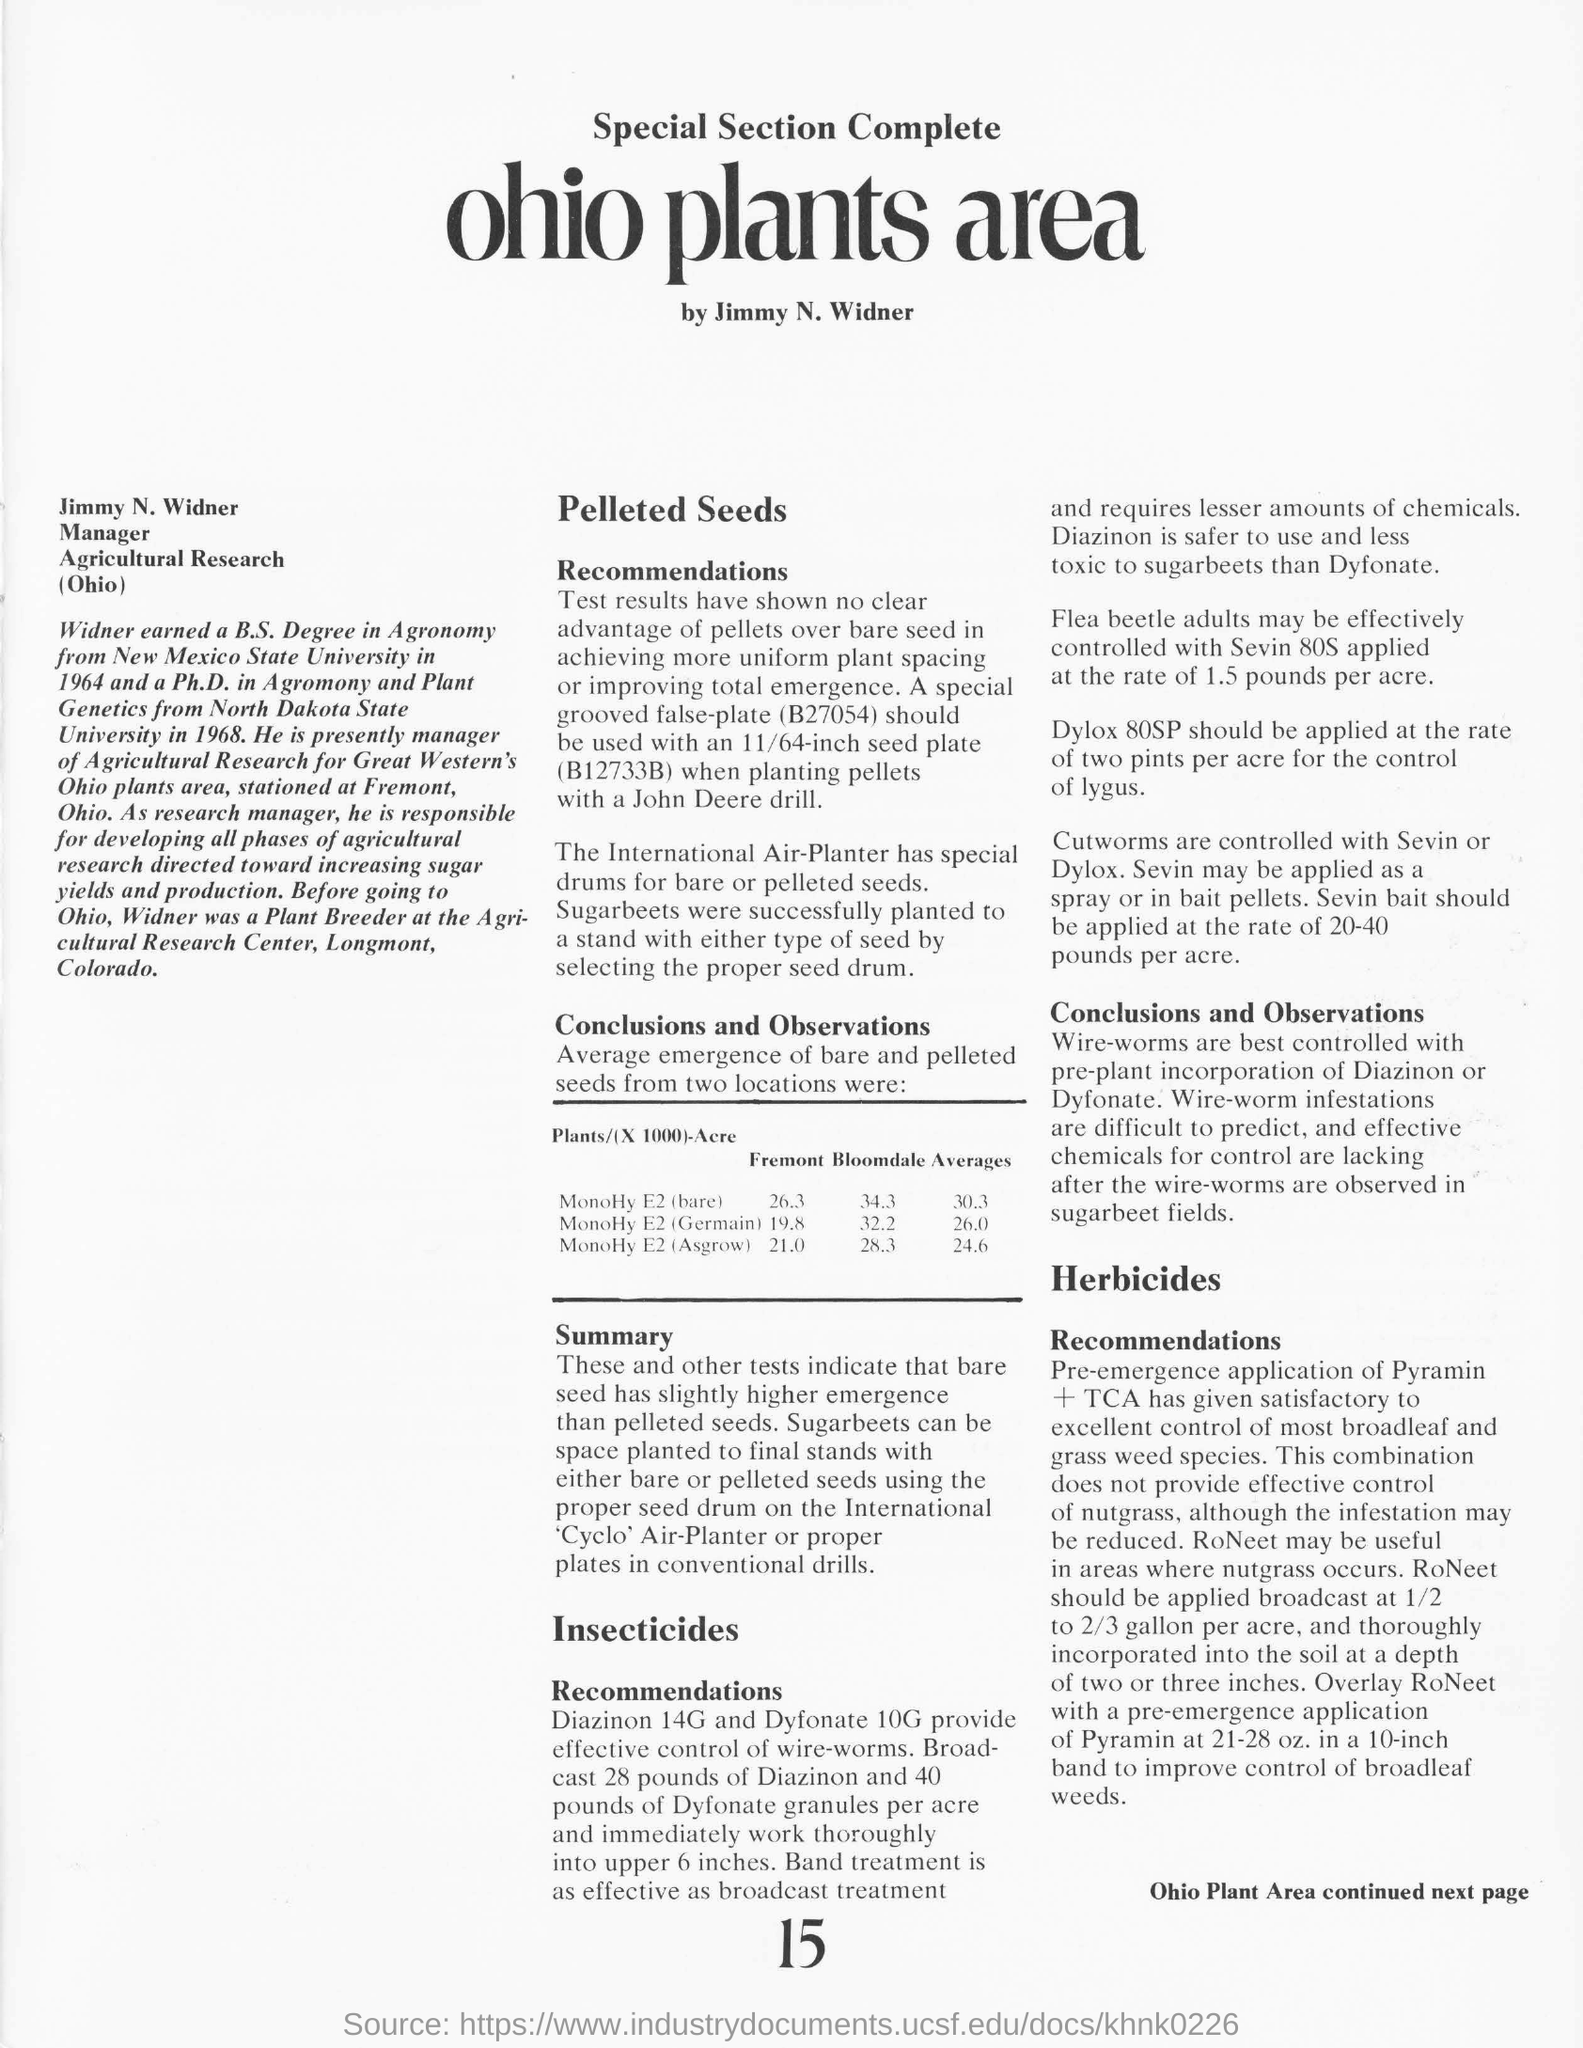Who is the manager of Agricultural Research (Ohio)?
Offer a very short reply. Jimmy N. Widner. Which two insecticides provide effective control of wire-worms?
Provide a short and direct response. Diazinon 14G and Dyfonate 10G. At what rate, Dylox 80SP should be applied for the control of lygus?
Ensure brevity in your answer.  Two pints per acre. What is the average emergence of MonoHy E2(bare) seeds  from Fremont and Bloomdale?
Your response must be concise. 30.3. 